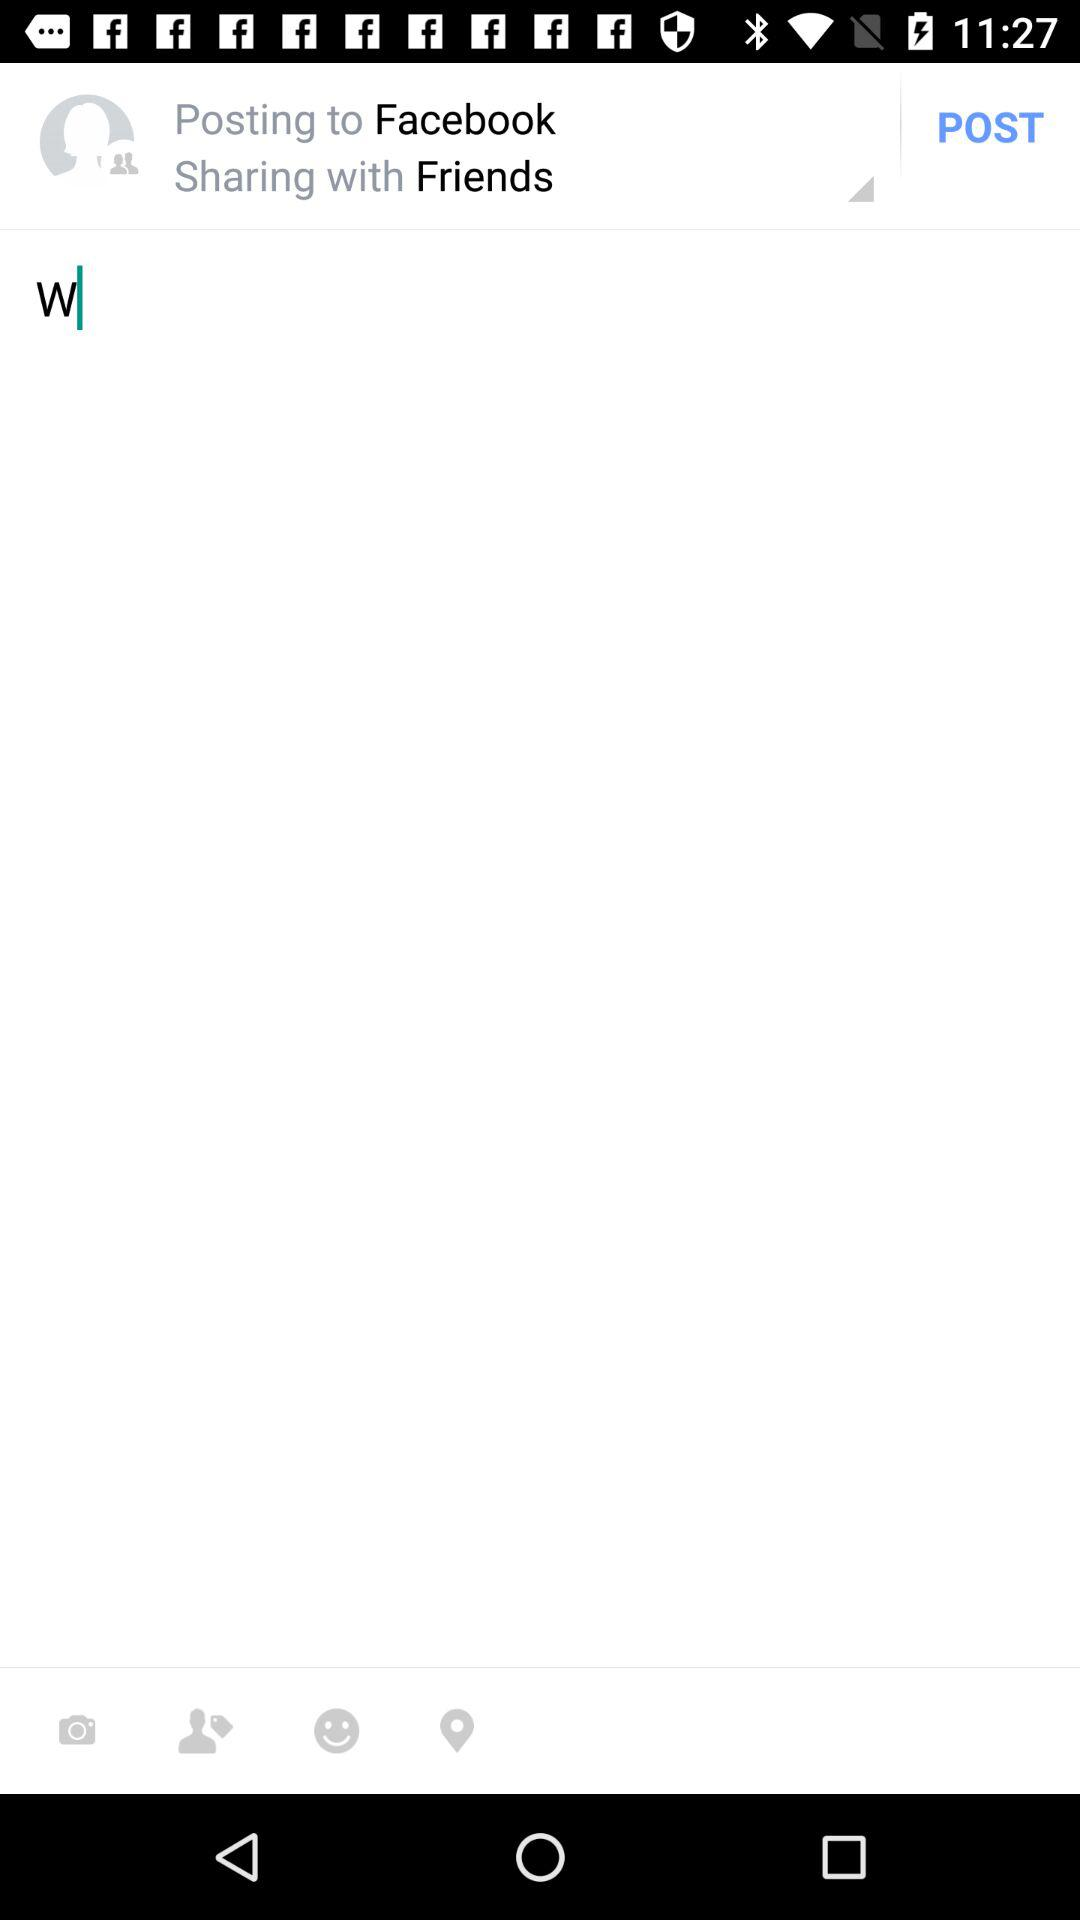With whom is the post being shared? The post is being shared with "Friends". 